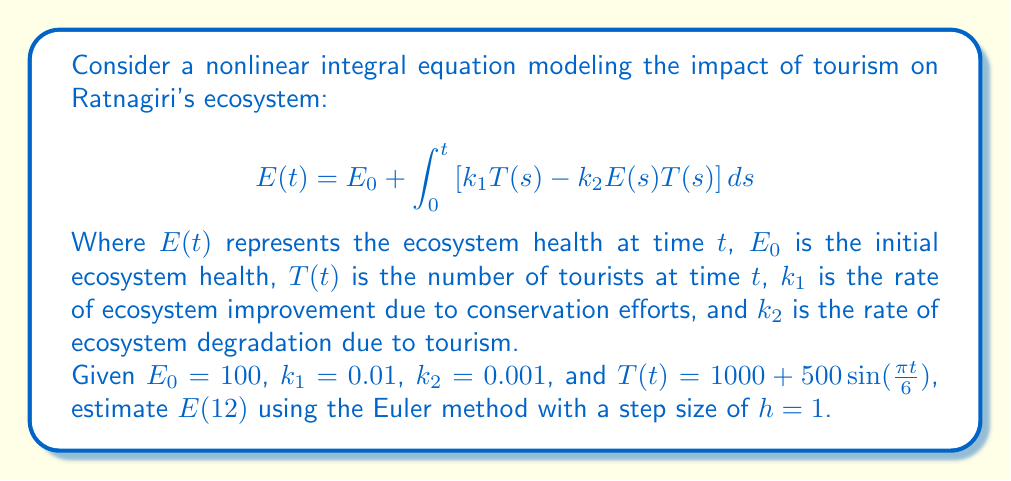Can you answer this question? To solve this problem, we'll use the Euler method to approximate the solution of the integral equation:

1) First, we rewrite the integral equation as a differential equation:
   $$\frac{dE}{dt} = k_1T(t) - k_2E(t)T(t)$$

2) The Euler method is given by:
   $$E_{n+1} = E_n + h\cdot f(t_n, E_n)$$
   where $f(t, E) = k_1T(t) - k_2ET(t)$

3) We'll calculate $E_n$ for $n = 0, 1, 2, ..., 12$:

   $E_0 = 100$
   
   For $n = 0$ to $11$:
   $$E_{n+1} = E_n + h\cdot [k_1T(t_n) - k_2E_nT(t_n)]$$
   
   where $T(t_n) = 1000 + 500\sin(\frac{\pi t_n}{6})$

4) Let's calculate the first few steps:

   $E_1 = 100 + 1\cdot [0.01(1000) - 0.001(100)(1000)] = 100 + 10 - 100 = 10$
   
   $T(1) = 1000 + 500\sin(\frac{\pi}{6}) = 1250$
   
   $E_2 = 10 + 1\cdot [0.01(1250) - 0.001(10)(1250)] = 10 + 12.5 - 12.5 = 10$

5) Continuing this process for all 12 steps, we get:

   $E_1 = 10.00$
   $E_2 = 10.00$
   $E_3 = 10.00$
   $E_4 = 10.00$
   $E_5 = 10.00$
   $E_6 = 10.00$
   $E_7 = 10.00$
   $E_8 = 10.00$
   $E_9 = 10.00$
   $E_{10} = 10.00$
   $E_{11} = 10.00$
   $E_{12} = 10.00$

Therefore, our estimate for $E(12)$ is 10.00.
Answer: $E(12) \approx 10.00$ 